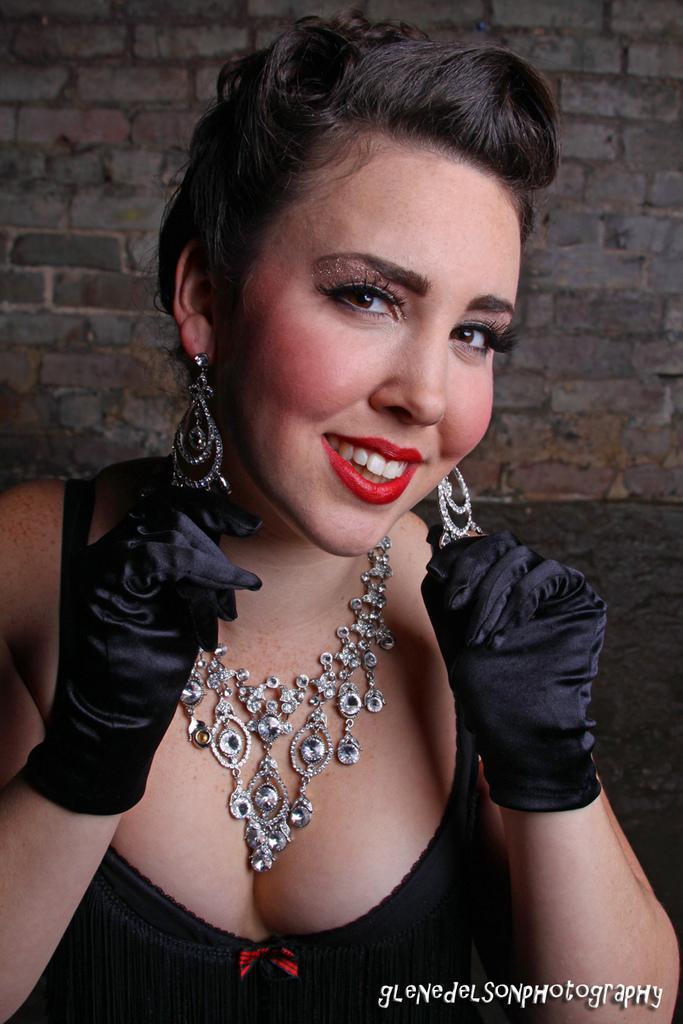In one or two sentences, can you explain what this image depicts? In this picture we can see a woman wearing ornaments on her ears and neck. She wore gloves on her hands and smiling. There is a brick wall in the background. 